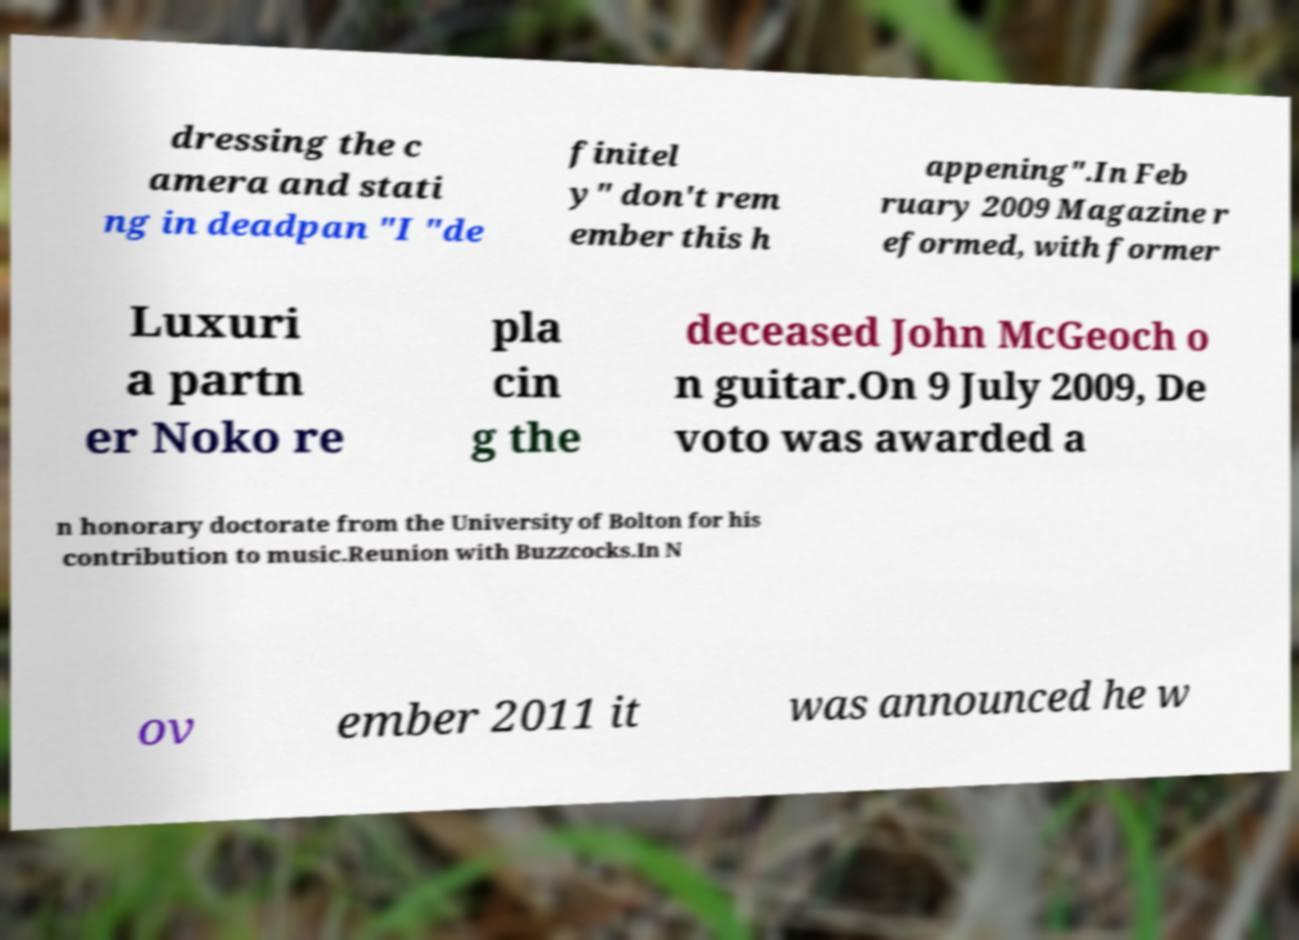I need the written content from this picture converted into text. Can you do that? dressing the c amera and stati ng in deadpan "I "de finitel y" don't rem ember this h appening".In Feb ruary 2009 Magazine r eformed, with former Luxuri a partn er Noko re pla cin g the deceased John McGeoch o n guitar.On 9 July 2009, De voto was awarded a n honorary doctorate from the University of Bolton for his contribution to music.Reunion with Buzzcocks.In N ov ember 2011 it was announced he w 